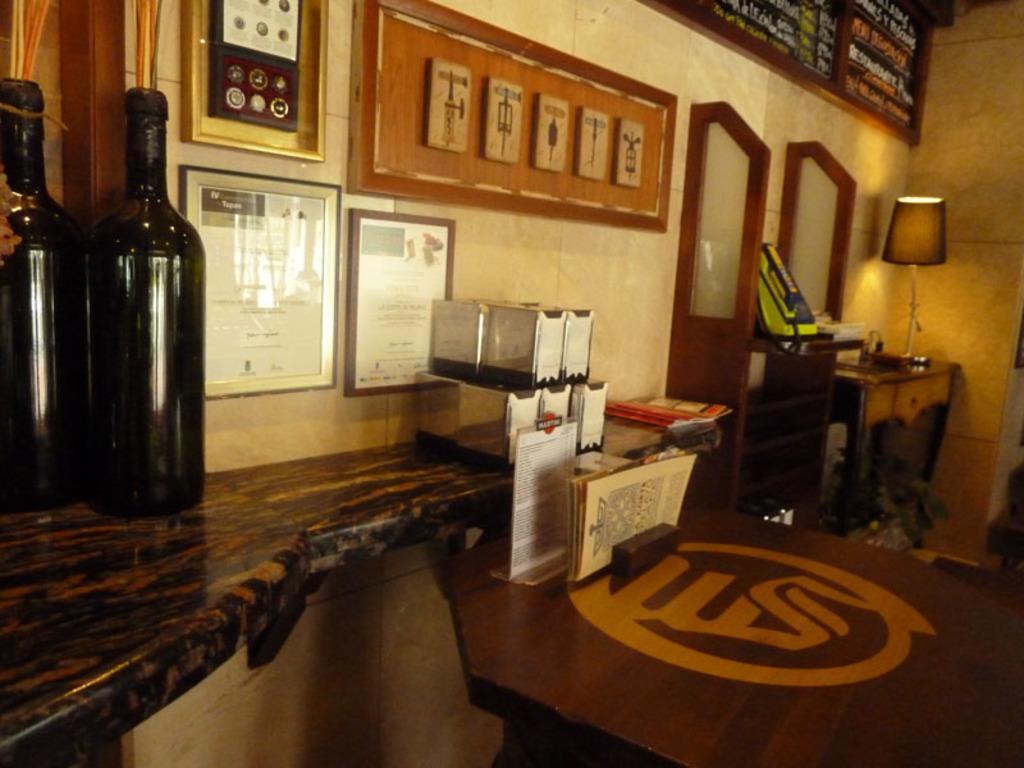Describe this image in one or two sentences. This is a picture of the inside of the house. In this picture on the top there is wall and on the left side there are two bottles and on the right side there is wall. Beside that wall there is one cupboard and on that cupboard there is one lamp beside that lamp there is another cupboard and in the middle there is one table and on that table there are some books, papers are there and on the top there are photo frames. 